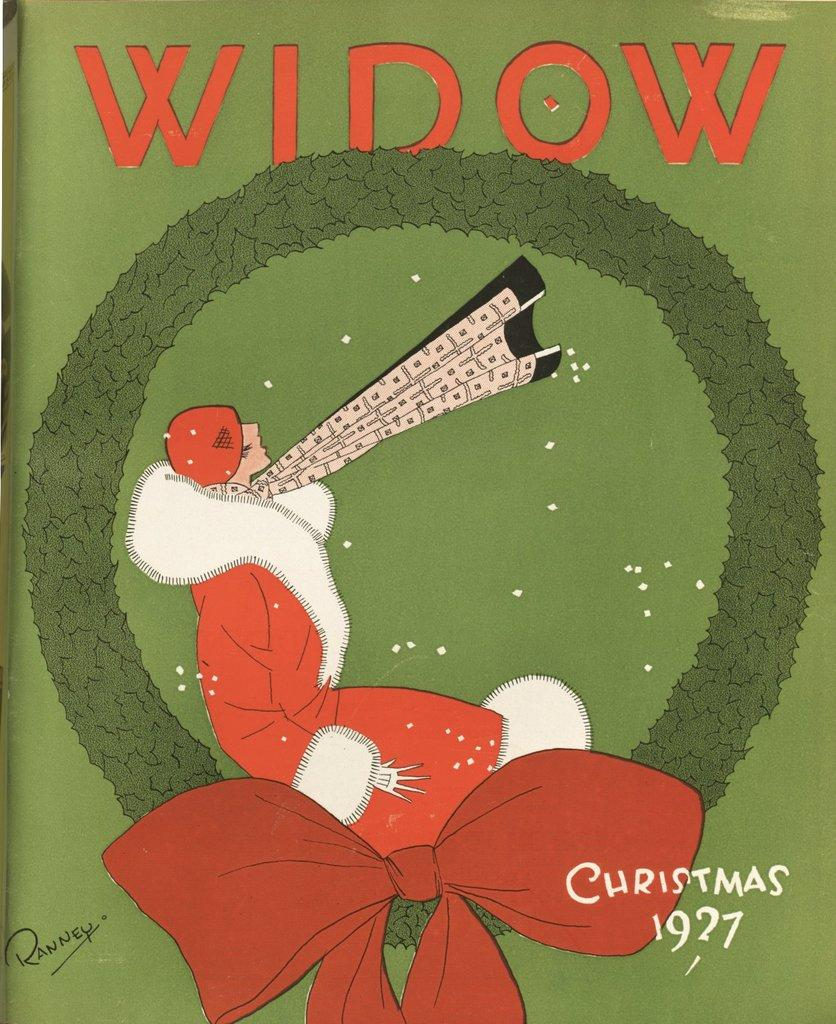What type of image is present in the picture? There is a cartoon image in the picture. What is depicted in the cartoon image? The cartoon image contains a person. Are there any words or labels present in the cartoon image? Yes, there are names present on the cartoon image. What type of railway can be seen in the image? There is no railway present in the image. How many children are visible in the image? The image does not depict any children; it contains a cartoon image with a person and names. What color is the stocking worn by the person in the image? The image does not show any stockings being worn by the person; it only contains a cartoon image with a person and names. 